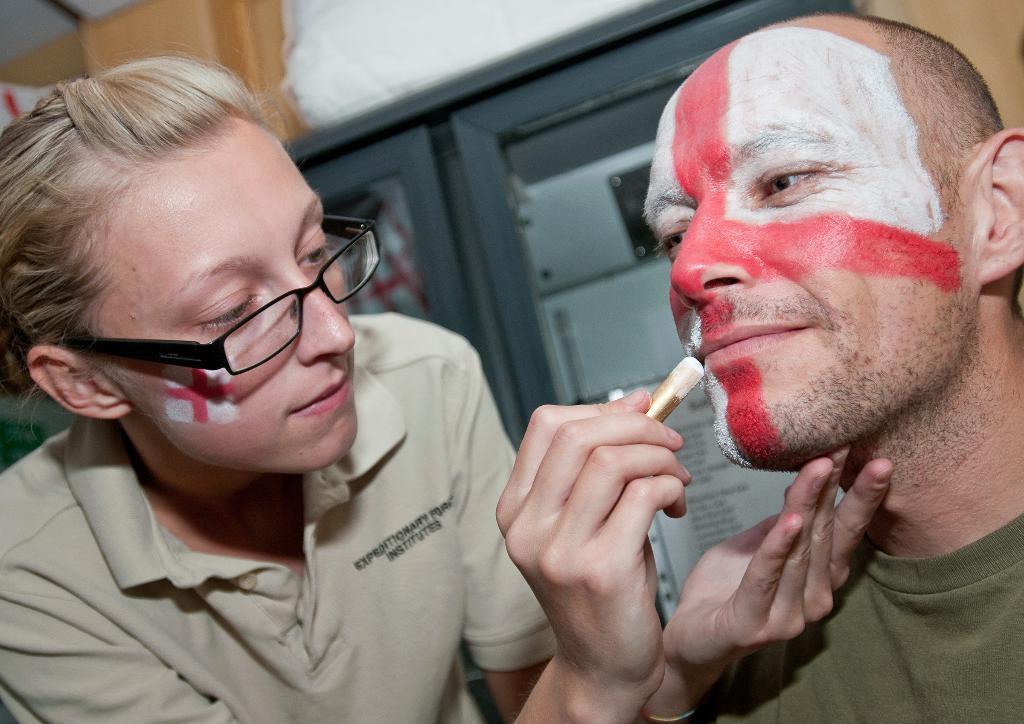In one or two sentences, can you explain what this image depicts? In the background we can see the objects. In this picture we can see a woman wearing spectacles and a t-shirt. She is holding an object in her hand and it seems like she is painting the face of a man. A man is smiling. 